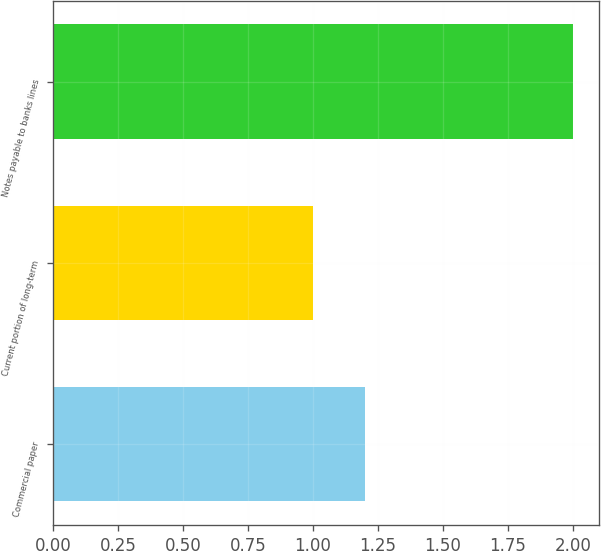Convert chart. <chart><loc_0><loc_0><loc_500><loc_500><bar_chart><fcel>Commercial paper<fcel>Current portion of long-term<fcel>Notes payable to banks lines<nl><fcel>1.2<fcel>1<fcel>2<nl></chart> 